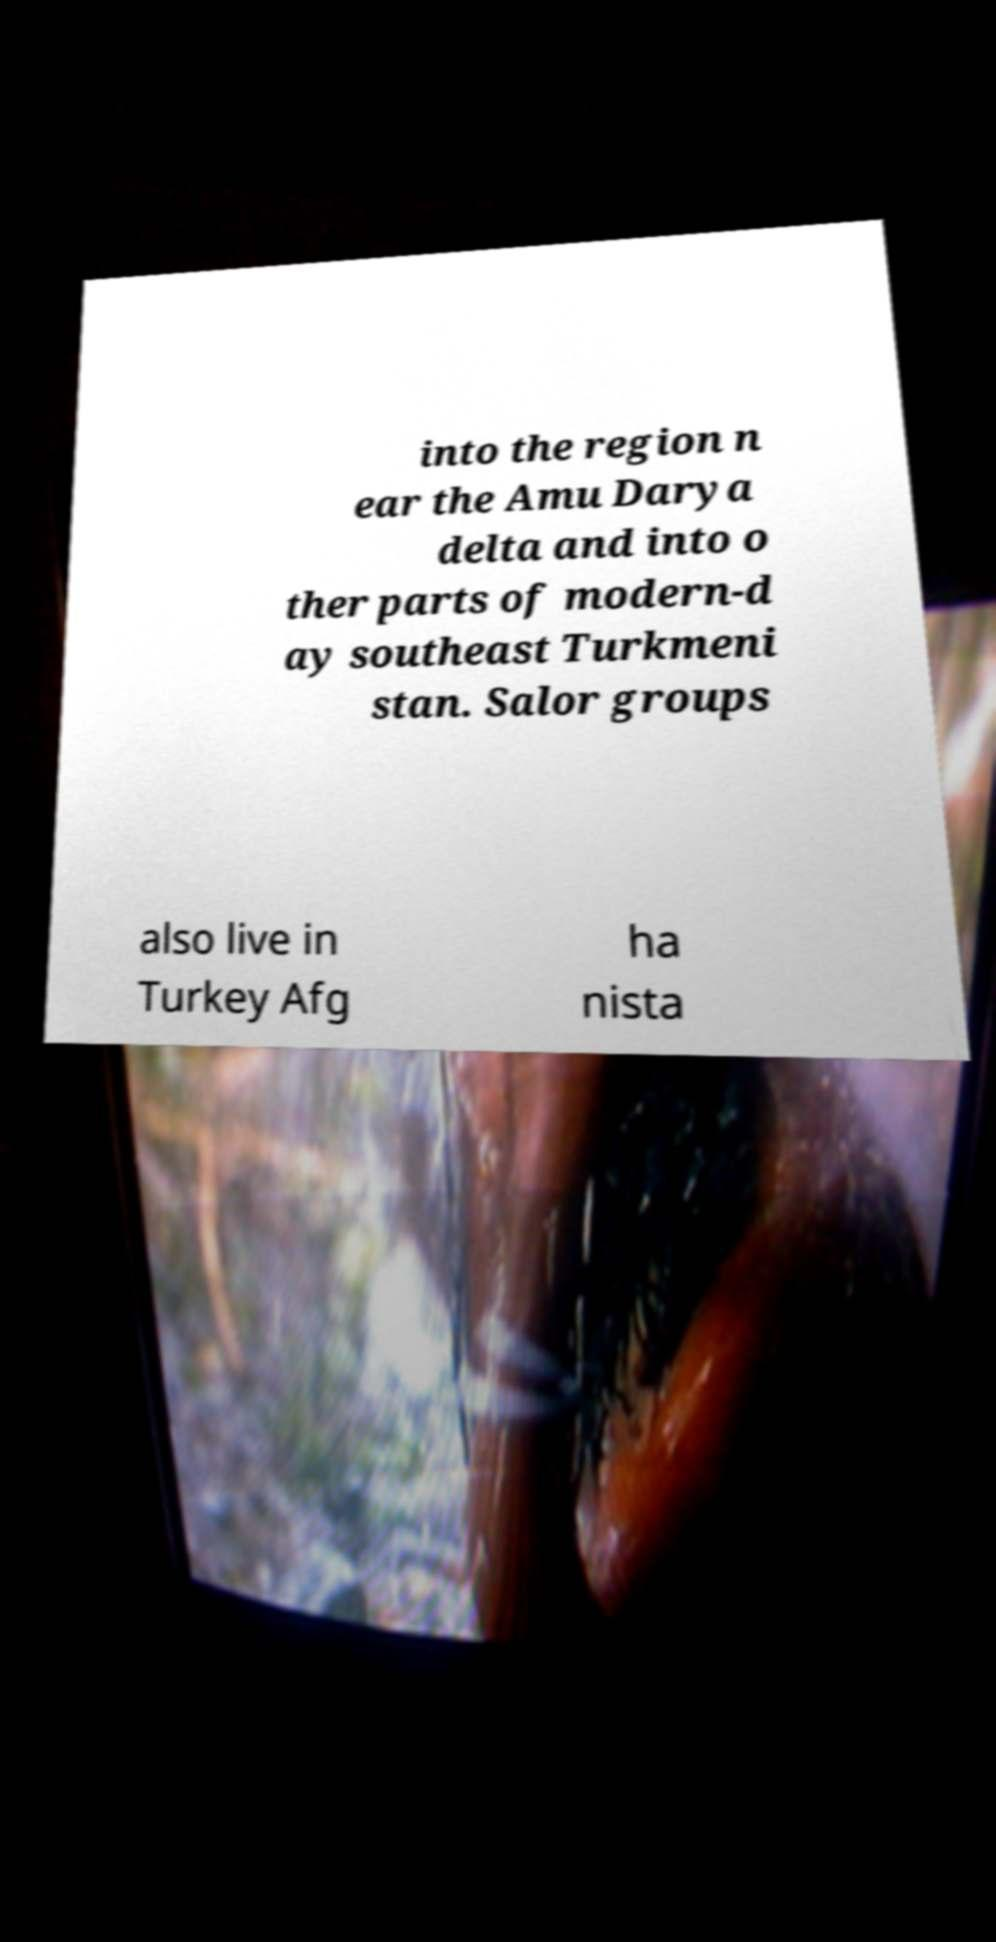There's text embedded in this image that I need extracted. Can you transcribe it verbatim? into the region n ear the Amu Darya delta and into o ther parts of modern-d ay southeast Turkmeni stan. Salor groups also live in Turkey Afg ha nista 